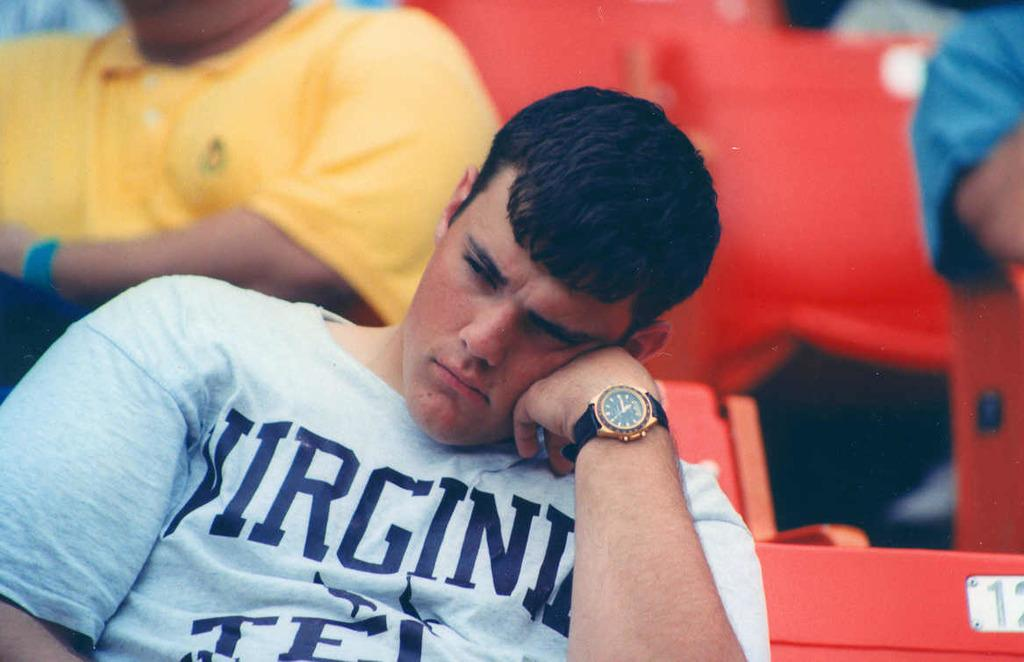<image>
Present a compact description of the photo's key features. A young man is wearing a Virginia shirt and rests his head on his hand. 